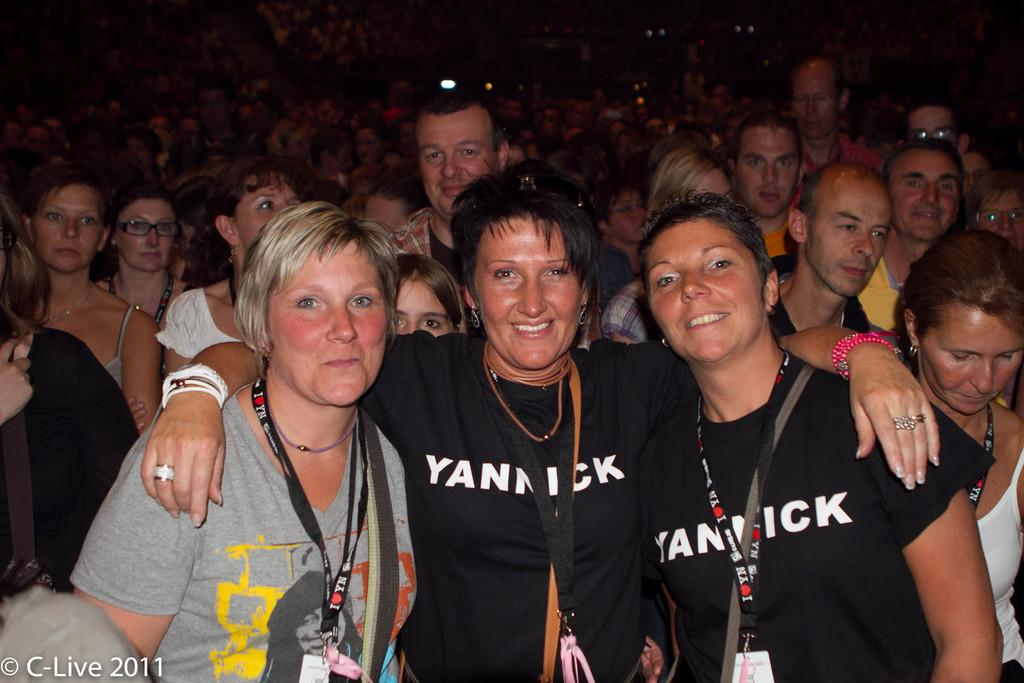How many people are in the image? There are three women in the image. What are the women doing in the image? The women are posing for a camera. What is the facial expression of the women in the image? The women are smiling. What can be seen in the background of the image? There is a crowd in the background of the image. What type of organization is the women answering questions for in the image? There is no indication in the image that the women are answering questions or participating in an organization. 